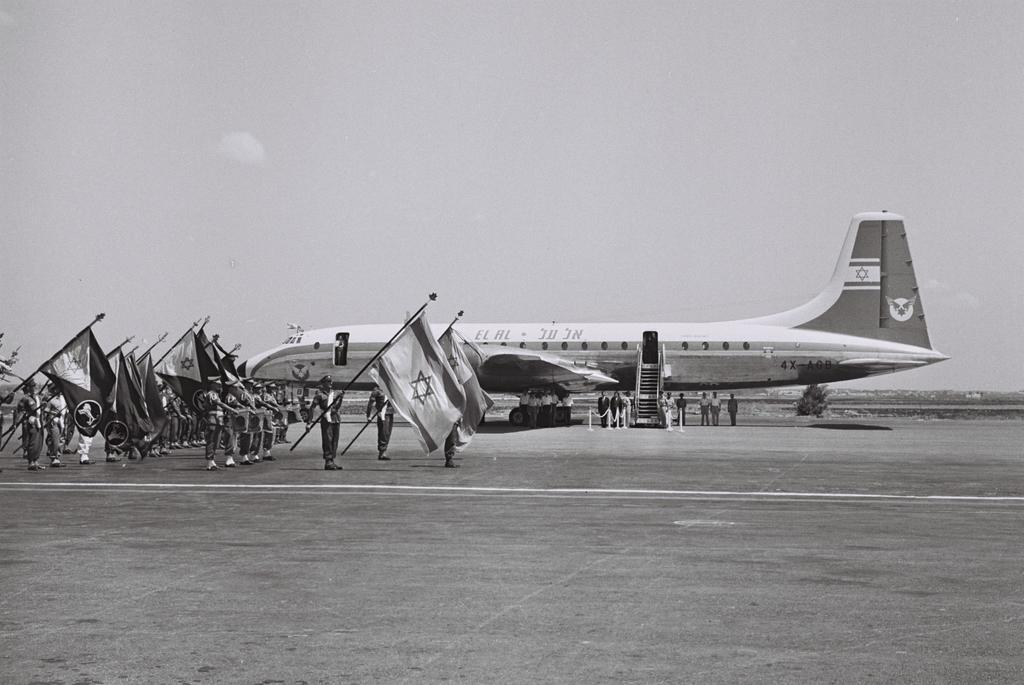What is the main subject of the image? The main subject of the image is a plane. Where is the plane located in the image? The plane is parked on the runway. What are the soldiers doing in front of the plane? The soldiers are standing in front of the plane and holding flags. What can be seen in the background of the image? The sky is visible in the image. What thought is expressed by the car in the image? There is no car present in the image, so it cannot express any thoughts. 